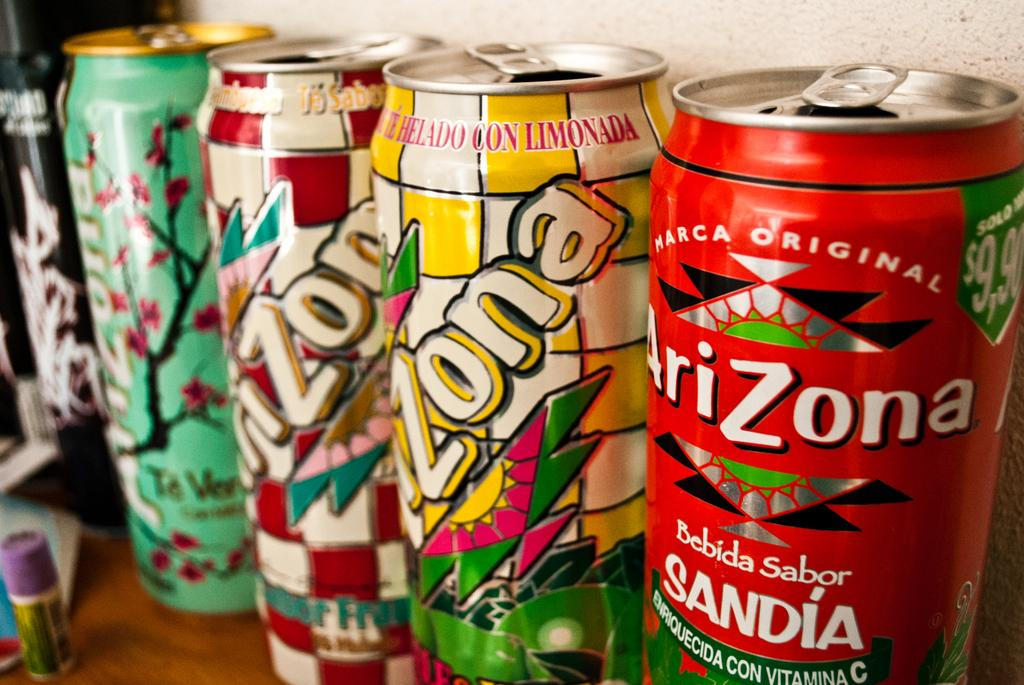<image>
Summarize the visual content of the image. A variety of Arizona tea cans, one is original and the other is lemonade. 